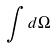<formula> <loc_0><loc_0><loc_500><loc_500>\int d \Omega</formula> 